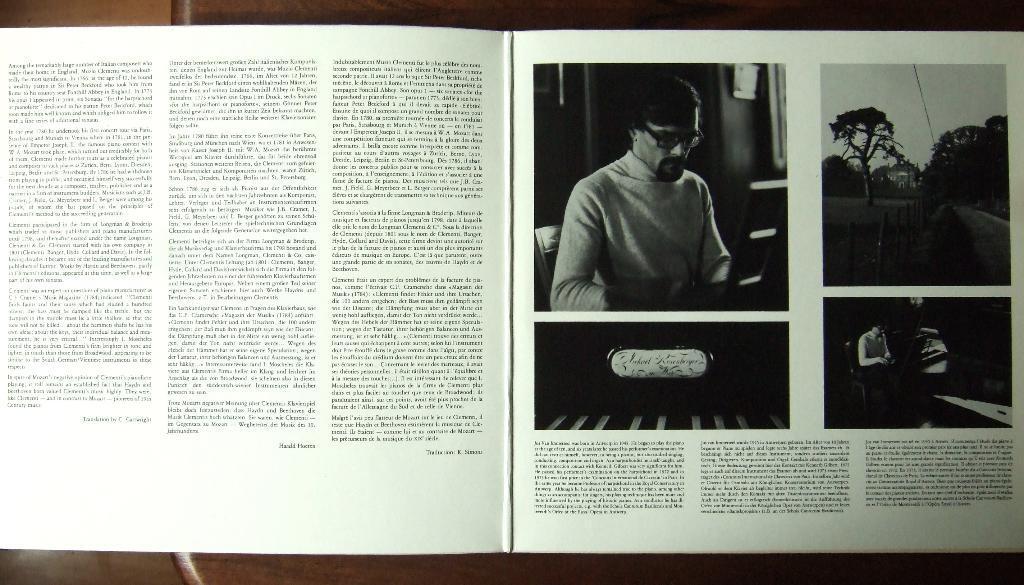In one or two sentences, can you explain what this image depicts? In this image there is a book having pages. The book is kept on a table. In the book there are few images and some text. Left side there is some text. Right side there is an image of a person wearing spectacles. Beside there is an image having a road and trees. Right bottom there is some text. 